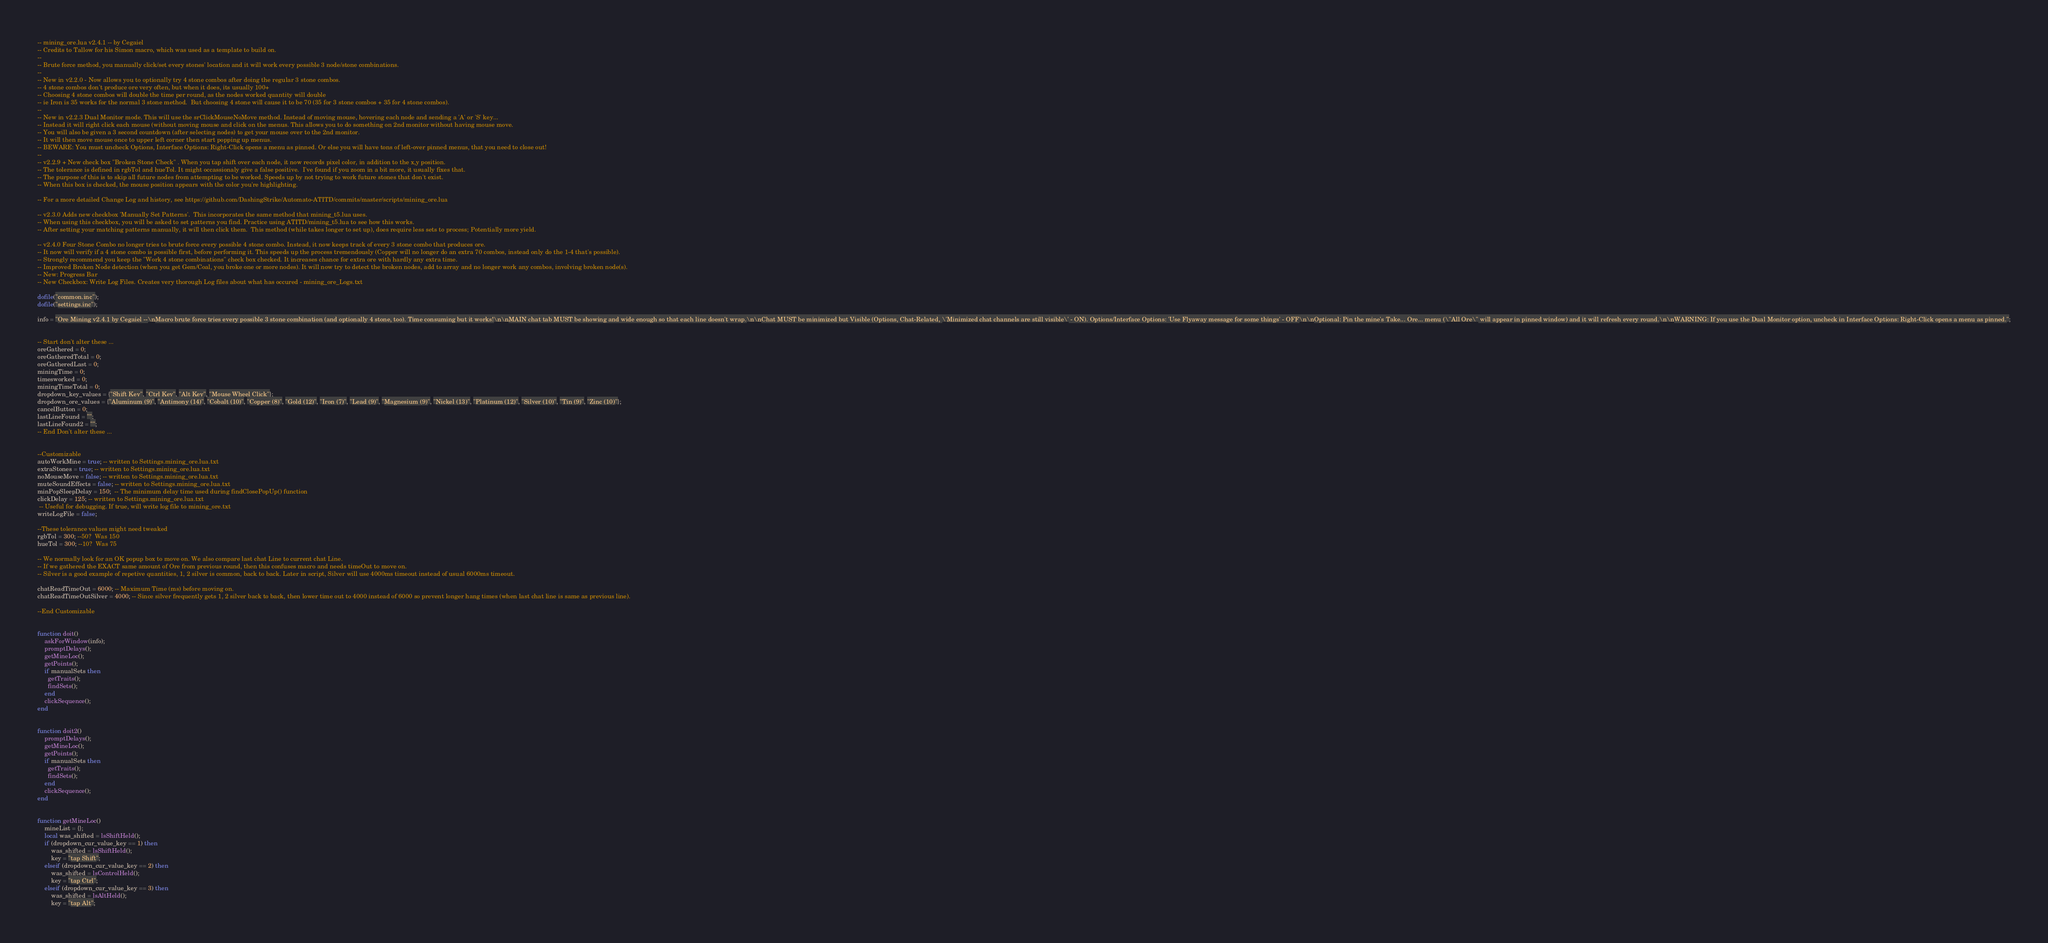<code> <loc_0><loc_0><loc_500><loc_500><_Lua_>-- mining_ore.lua v2.4.1 -- by Cegaiel
-- Credits to Tallow for his Simon macro, which was used as a template to build on.
--
-- Brute force method, you manually click/set every stones' location and it will work every possible 3 node/stone combinations.
--
-- New in v2.2.0 - Now allows you to optionally try 4 stone combos after doing the regular 3 stone combos.
-- 4 stone combos don't produce ore very often, but when it does, its usually 100+
-- Choosing 4 stone combos will double the time per round, as the nodes worked quantity will double
-- ie Iron is 35 works for the normal 3 stone method.  But choosing 4 stone will cause it to be 70 (35 for 3 stone combos + 35 for 4 stone combos).
--
-- New in v2.2.3 Dual Monitor mode. This will use the srClickMouseNoMove method. Instead of moving mouse, hovering each node and sending a 'A' or 'S' key...
-- Instead it will right click each mouse (without moving mouse and click on the menus. This allows you to do something on 2nd monitor without having mouse move.
-- You will also be given a 3 second countdown (after selecting nodes) to get your mouse over to the 2nd monitor.
-- It will then move mouse once to upper left corner then start popping up menus.
-- BEWARE: You must uncheck Options, Interface Options: Right-Click opens a menu as pinned. Or else you will have tons of left-over pinned menus, that you need to close out!
--
-- v2.2.9 + New check box "Broken Stone Check" . When you tap shift over each node, it now records pixel color, in addition to the x,y position.
-- The tolerance is defined in rgbTol and hueTol. It might occassionaly give a false positive.  I've found if you zoom in a bit more, it usually fixes that.
-- The purpose of this is to skip all future nodes from attempting to be worked. Speeds up by not trying to work future stones that don't exist.
-- When this box is checked, the mouse position appears with the color you're highlighting.

-- For a more detailed Change Log and history, see https://github.com/DashingStrike/Automato-ATITD/commits/master/scripts/mining_ore.lua

-- v2.3.0 Adds new checkbox 'Manually Set Patterns'.  This incorporates the same method that mining_t5.lua uses.
-- When using this checkbox, you will be asked to set patterns you find. Practice using ATITD/mining_t5.lua to see how this works.
-- After setting your matching patterns manually, it will then click them.  This method (while takes longer to set up), does require less sets to process; Potentially more yield.

-- v2.4.0 Four Stone Combo no longer tries to brute force every possible 4 stone combo. Instead, it now keeps track of every 3 stone combo that produces ore.
-- It now will verify if a 4 stone combo is possible first, before performing it. This speeds up the process tremendously (Copper will no longer do an extra 70 combos, instead only do the 1-4 that's possible).
-- Strongly recommend you keep the "Work 4 stone combinations" check box checked. It increases chance for extra ore with hardly any extra time.
-- Improved Broken Node detection (when you get Gem/Coal, you broke one or more nodes). It will now try to detect the broken nodes, add to array and no longer work any combos, involving broken node(s).
-- New: Progress Bar
-- New Checkbox: Write Log Files. Creates very thorough Log files about what has occured - mining_ore_Logs.txt

dofile("common.inc");
dofile("settings.inc");

info = "Ore Mining v2.4.1 by Cegaiel --\nMacro brute force tries every possible 3 stone combination (and optionally 4 stone, too). Time consuming but it works!\n\nMAIN chat tab MUST be showing and wide enough so that each line doesn't wrap.\n\nChat MUST be minimized but Visible (Options, Chat-Related, \'Minimized chat channels are still visible\' - ON). Options/Interface Options: 'Use Flyaway message for some things' - OFF\n\nOptional: Pin the mine's Take... Ore... menu (\"All Ore\" will appear in pinned window) and it will refresh every round.\n\nWARNING: If you use the Dual Monitor option, uncheck in Interface Options: Right-Click opens a menu as pinned.";


-- Start don't alter these ...
oreGathered = 0;
oreGatheredTotal = 0;
oreGatheredLast = 0;
miningTime = 0;
timesworked = 0;
miningTimeTotal = 0;
dropdown_key_values = {"Shift Key", "Ctrl Key", "Alt Key", "Mouse Wheel Click"};
dropdown_ore_values = {"Aluminum (9)", "Antimony (14)", "Cobalt (10)", "Copper (8)", "Gold (12)", "Iron (7)", "Lead (9)", "Magnesium (9)", "Nickel (13)", "Platinum (12)", "Silver (10)", "Tin (9)", "Zinc (10)"};
cancelButton = 0;
lastLineFound = "";
lastLineFound2 = "";
-- End Don't alter these ...


--Customizable
autoWorkMine = true; -- written to Settings.mining_ore.lua.txt
extraStones = true; -- written to Settings.mining_ore.lua.txt
noMouseMove = false; -- written to Settings.mining_ore.lua.txt
muteSoundEffects = false; -- written to Settings.mining_ore.lua.txt
minPopSleepDelay = 150;  -- The minimum delay time used during findClosePopUp() function
clickDelay = 125; -- written to Settings.mining_ore.lua.txt
 -- Useful for debugging. If true, will write log file to mining_ore.txt
writeLogFile = false;

--These tolerance values might need tweaked
rgbTol = 300; --50?  Was 150
hueTol = 300; --10?  Was 75

-- We normally look for an OK popup box to move on. We also compare last chat Line to current chat Line.
-- If we gathered the EXACT same amount of Ore from previous round, then this confuses macro and needs timeOut to move on.
-- Silver is a good example of repetive quantities, 1, 2 silver is common, back to back. Later in script, Silver will use 4000ms timeout instead of usual 6000ms timeout.

chatReadTimeOut = 6000; -- Maximum Time (ms) before moving on.
chatReadTimeOutSilver = 4000; -- Since silver frequently gets 1, 2 silver back to back, then lower time out to 4000 instead of 6000 so prevent longer hang times (when last chat line is same as previous line).

--End Customizable


function doit()
    askForWindow(info);
    promptDelays();
    getMineLoc();
    getPoints();
    if manualSets then
      getTraits();
      findSets();
    end
    clickSequence();
end


function doit2()
    promptDelays();
    getMineLoc();
    getPoints();
    if manualSets then
      getTraits();
      findSets();
    end
    clickSequence();
end


function getMineLoc()
    mineList = {};
    local was_shifted = lsShiftHeld();
    if (dropdown_cur_value_key == 1) then
        was_shifted = lsShiftHeld();
        key = "tap Shift";
    elseif (dropdown_cur_value_key == 2) then
        was_shifted = lsControlHeld();
        key = "tap Ctrl";
    elseif (dropdown_cur_value_key == 3) then
        was_shifted = lsAltHeld();
        key = "tap Alt";</code> 